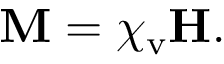Convert formula to latex. <formula><loc_0><loc_0><loc_500><loc_500>M = \chi _ { v } H .</formula> 